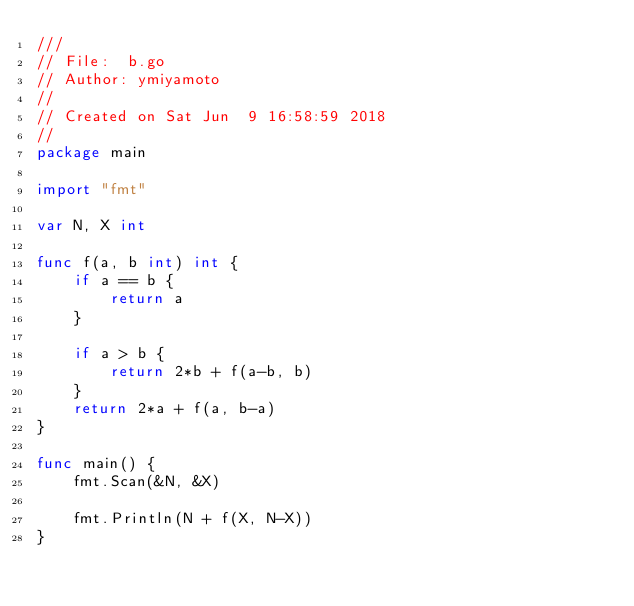Convert code to text. <code><loc_0><loc_0><loc_500><loc_500><_Go_>///
// File:  b.go
// Author: ymiyamoto
//
// Created on Sat Jun  9 16:58:59 2018
//
package main

import "fmt"

var N, X int

func f(a, b int) int {
	if a == b {
		return a
	}

	if a > b {
		return 2*b + f(a-b, b)
	}
	return 2*a + f(a, b-a)
}

func main() {
	fmt.Scan(&N, &X)

	fmt.Println(N + f(X, N-X))
}
</code> 